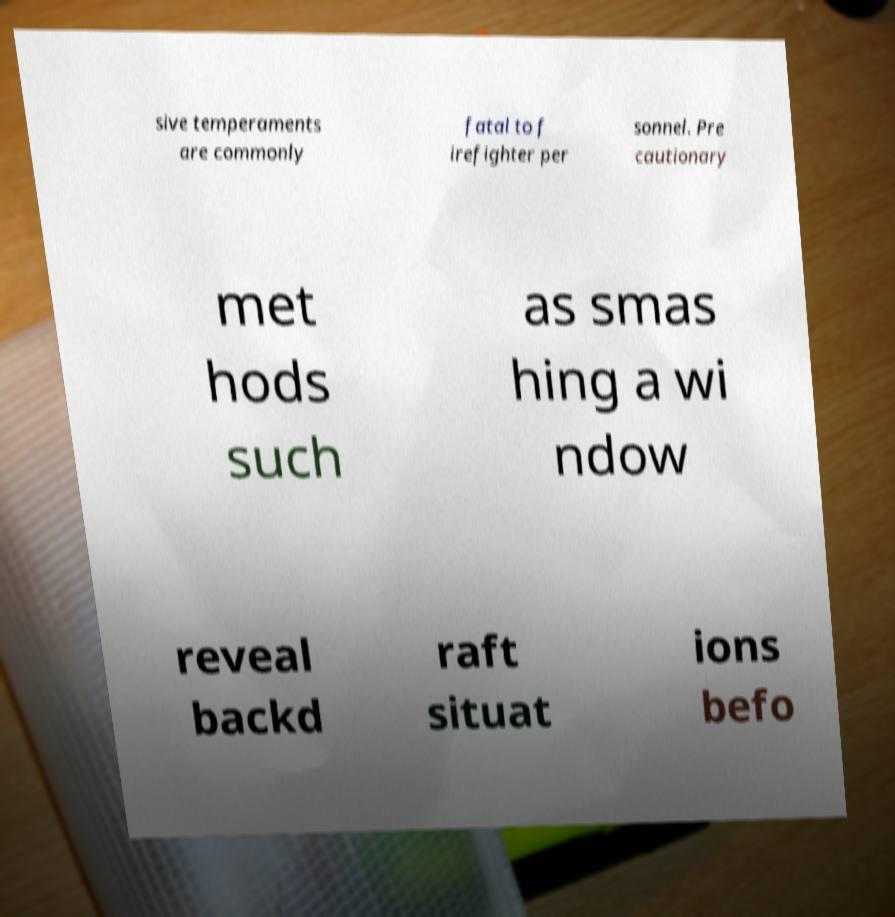Could you extract and type out the text from this image? sive temperaments are commonly fatal to f irefighter per sonnel. Pre cautionary met hods such as smas hing a wi ndow reveal backd raft situat ions befo 